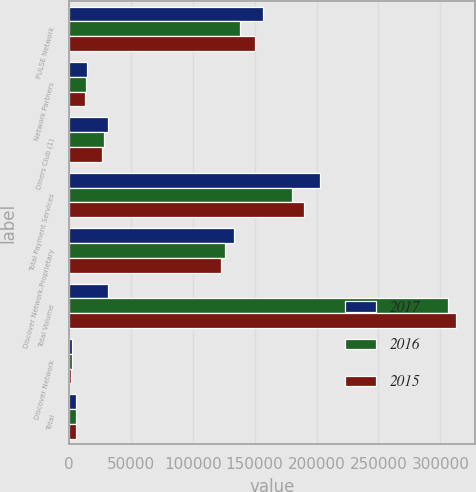Convert chart. <chart><loc_0><loc_0><loc_500><loc_500><stacked_bar_chart><ecel><fcel>PULSE Network<fcel>Network Partners<fcel>Diners Club (1)<fcel>Total Payment Services<fcel>Discover Network-Proprietary<fcel>Total Volume<fcel>Discover Network<fcel>Total<nl><fcel>2017<fcel>157128<fcel>14213<fcel>31544<fcel>202885<fcel>133044<fcel>31544<fcel>2240<fcel>6096<nl><fcel>2016<fcel>138003<fcel>13833<fcel>28601<fcel>180437<fcel>126144<fcel>306581<fcel>2125<fcel>5581<nl><fcel>2015<fcel>150145<fcel>12965<fcel>26567<fcel>189677<fcel>122726<fcel>312403<fcel>2033<fcel>5923<nl></chart> 